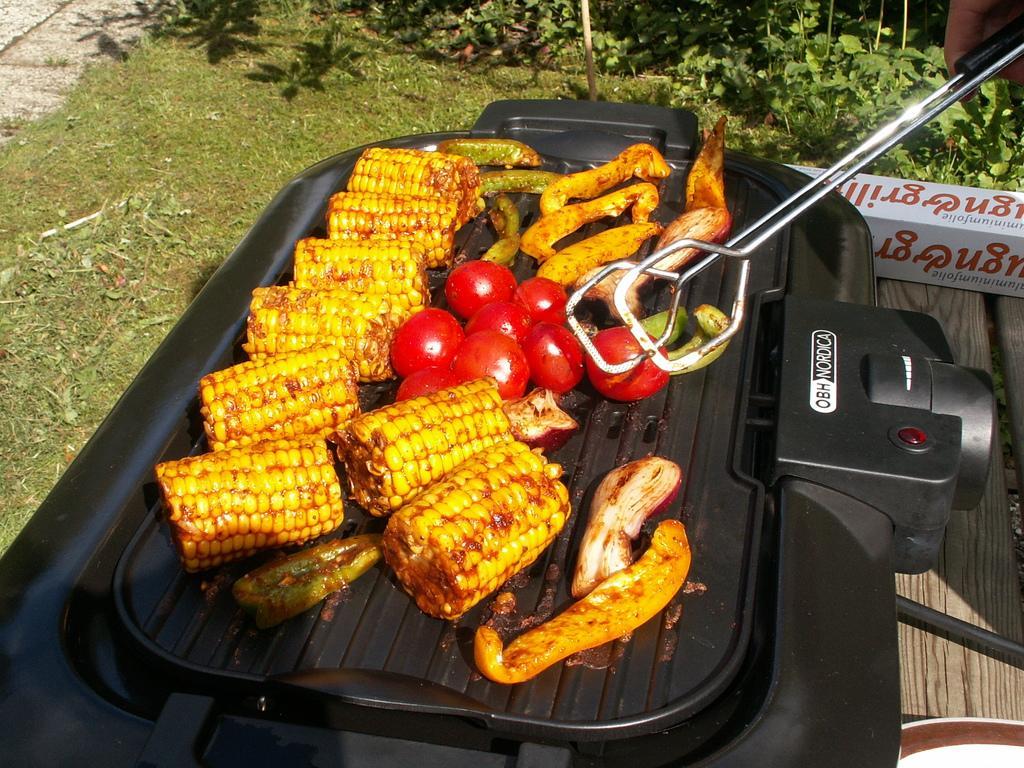How would you summarize this image in a sentence or two? In this image we can see food on a black object. In the top right, we can see a person holding an object. On the right side, we can see few objects on a surface. At the top we can see grass and a group of plants. 